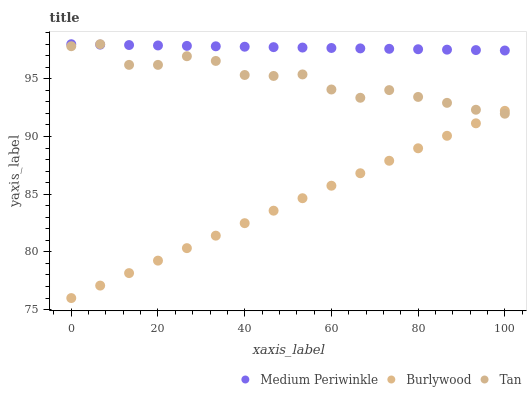Does Burlywood have the minimum area under the curve?
Answer yes or no. Yes. Does Medium Periwinkle have the maximum area under the curve?
Answer yes or no. Yes. Does Tan have the minimum area under the curve?
Answer yes or no. No. Does Tan have the maximum area under the curve?
Answer yes or no. No. Is Burlywood the smoothest?
Answer yes or no. Yes. Is Tan the roughest?
Answer yes or no. Yes. Is Medium Periwinkle the smoothest?
Answer yes or no. No. Is Medium Periwinkle the roughest?
Answer yes or no. No. Does Burlywood have the lowest value?
Answer yes or no. Yes. Does Tan have the lowest value?
Answer yes or no. No. Does Medium Periwinkle have the highest value?
Answer yes or no. Yes. Is Burlywood less than Medium Periwinkle?
Answer yes or no. Yes. Is Medium Periwinkle greater than Burlywood?
Answer yes or no. Yes. Does Tan intersect Burlywood?
Answer yes or no. Yes. Is Tan less than Burlywood?
Answer yes or no. No. Is Tan greater than Burlywood?
Answer yes or no. No. Does Burlywood intersect Medium Periwinkle?
Answer yes or no. No. 